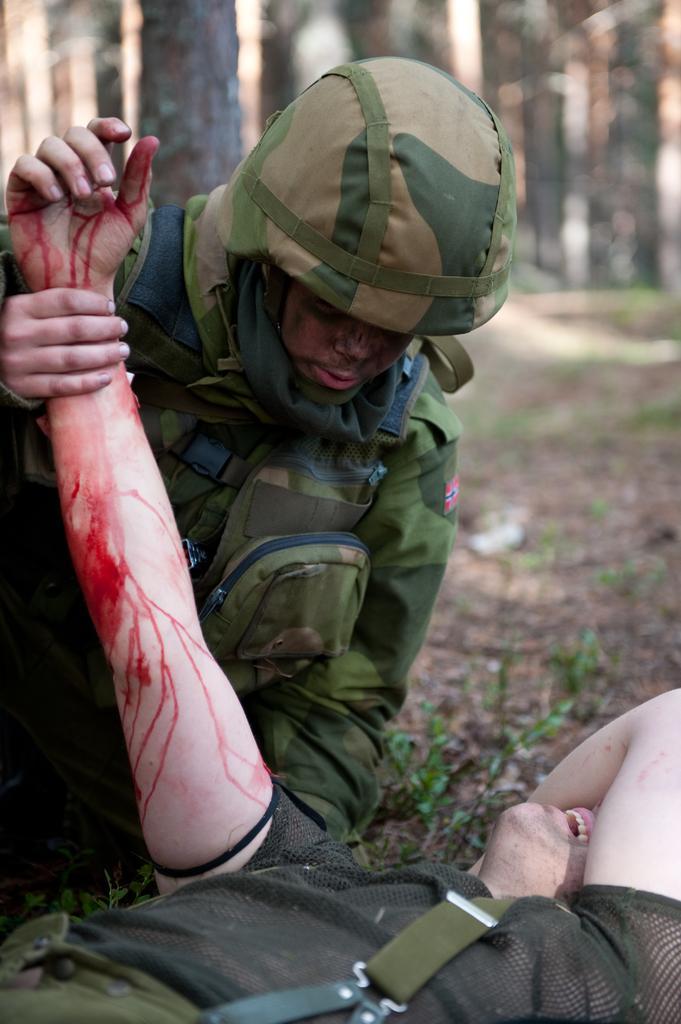How would you summarize this image in a sentence or two? In this image we can see two persons, one of them is lying on the ground, his hand is bleeding, second person is holding another person's hand, also we can see the trees, and the background is blurred. 